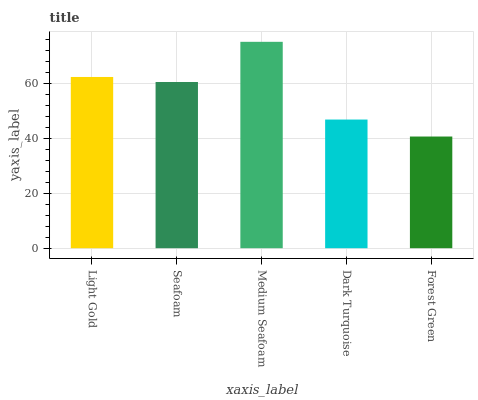Is Seafoam the minimum?
Answer yes or no. No. Is Seafoam the maximum?
Answer yes or no. No. Is Light Gold greater than Seafoam?
Answer yes or no. Yes. Is Seafoam less than Light Gold?
Answer yes or no. Yes. Is Seafoam greater than Light Gold?
Answer yes or no. No. Is Light Gold less than Seafoam?
Answer yes or no. No. Is Seafoam the high median?
Answer yes or no. Yes. Is Seafoam the low median?
Answer yes or no. Yes. Is Medium Seafoam the high median?
Answer yes or no. No. Is Forest Green the low median?
Answer yes or no. No. 